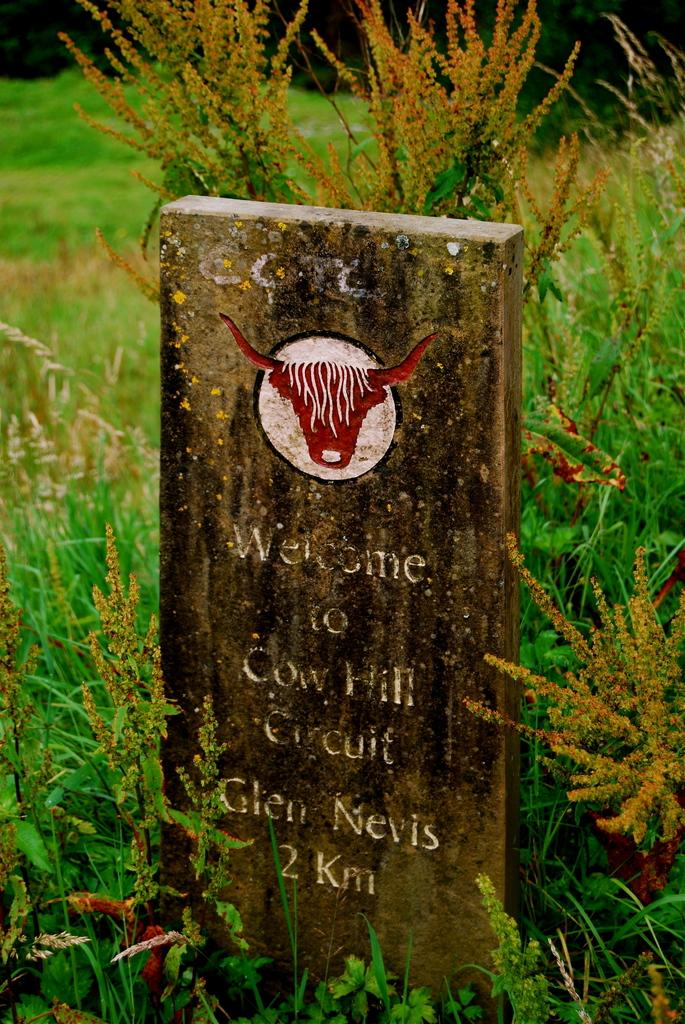What is the main subject in the middle of the image? There is a carved stone in the middle of the image. What can be seen around the carved stone? There are plants surrounding the carved stone. What type of behavior can be observed in the clock in the image? There is no clock present in the image, so it is not possible to observe any behavior. 